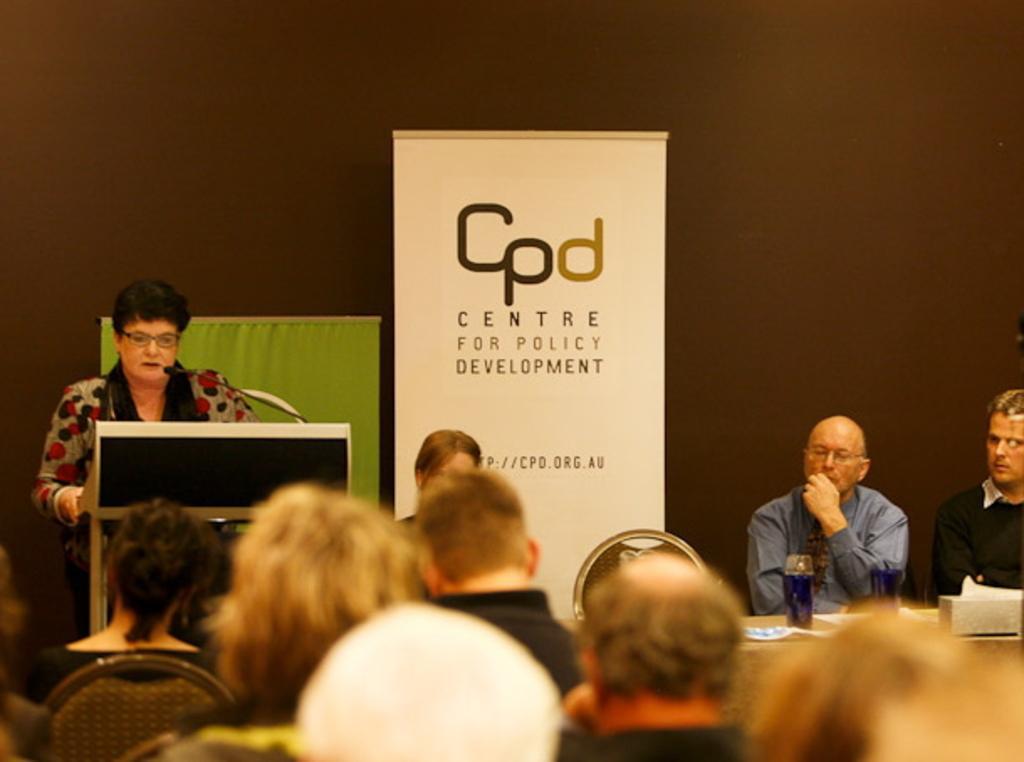Could you give a brief overview of what you see in this image? In this image there is a person standing behind the podium having a mike on it. Behind him there are two banners. Bottom of image there are few persons sitting on the chairs. Two persons are sitting behind the table which is having a bottle and few objects on it. Background there is a wall. 